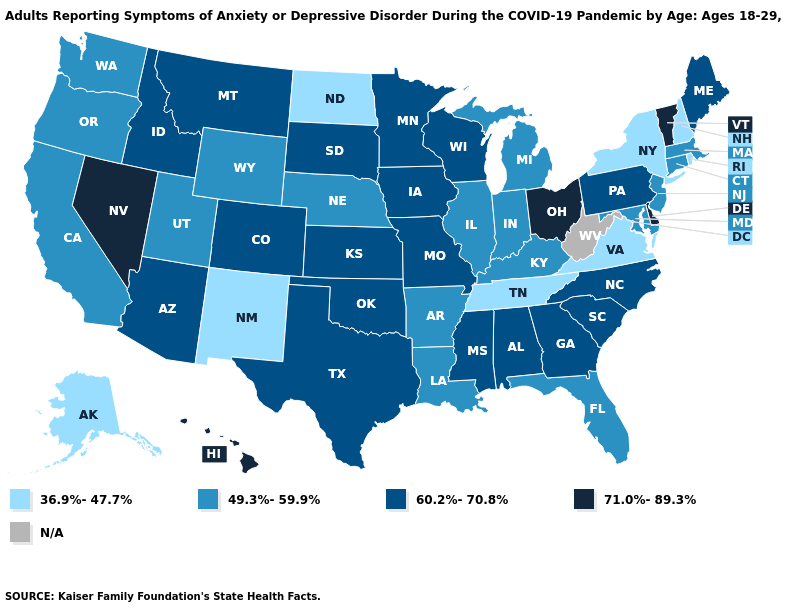What is the value of Tennessee?
Quick response, please. 36.9%-47.7%. Which states have the lowest value in the USA?
Answer briefly. Alaska, New Hampshire, New Mexico, New York, North Dakota, Rhode Island, Tennessee, Virginia. Name the states that have a value in the range 60.2%-70.8%?
Answer briefly. Alabama, Arizona, Colorado, Georgia, Idaho, Iowa, Kansas, Maine, Minnesota, Mississippi, Missouri, Montana, North Carolina, Oklahoma, Pennsylvania, South Carolina, South Dakota, Texas, Wisconsin. How many symbols are there in the legend?
Keep it brief. 5. Does Maine have the highest value in the Northeast?
Write a very short answer. No. Among the states that border Georgia , which have the highest value?
Keep it brief. Alabama, North Carolina, South Carolina. Name the states that have a value in the range 36.9%-47.7%?
Quick response, please. Alaska, New Hampshire, New Mexico, New York, North Dakota, Rhode Island, Tennessee, Virginia. Does Delaware have the highest value in the South?
Keep it brief. Yes. How many symbols are there in the legend?
Concise answer only. 5. Name the states that have a value in the range N/A?
Answer briefly. West Virginia. Which states hav the highest value in the MidWest?
Keep it brief. Ohio. Among the states that border New Jersey , which have the highest value?
Short answer required. Delaware. What is the value of New Mexico?
Answer briefly. 36.9%-47.7%. Name the states that have a value in the range 36.9%-47.7%?
Quick response, please. Alaska, New Hampshire, New Mexico, New York, North Dakota, Rhode Island, Tennessee, Virginia. 